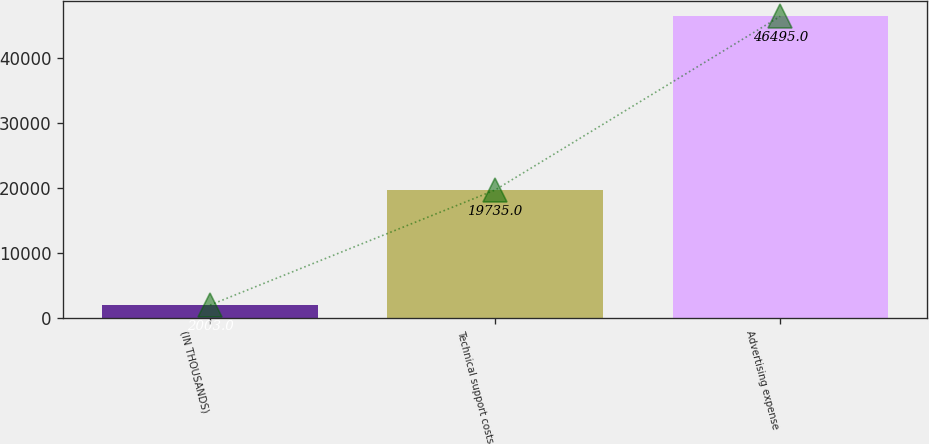<chart> <loc_0><loc_0><loc_500><loc_500><bar_chart><fcel>(IN THOUSANDS)<fcel>Technical support costs<fcel>Advertising expense<nl><fcel>2003<fcel>19735<fcel>46495<nl></chart> 